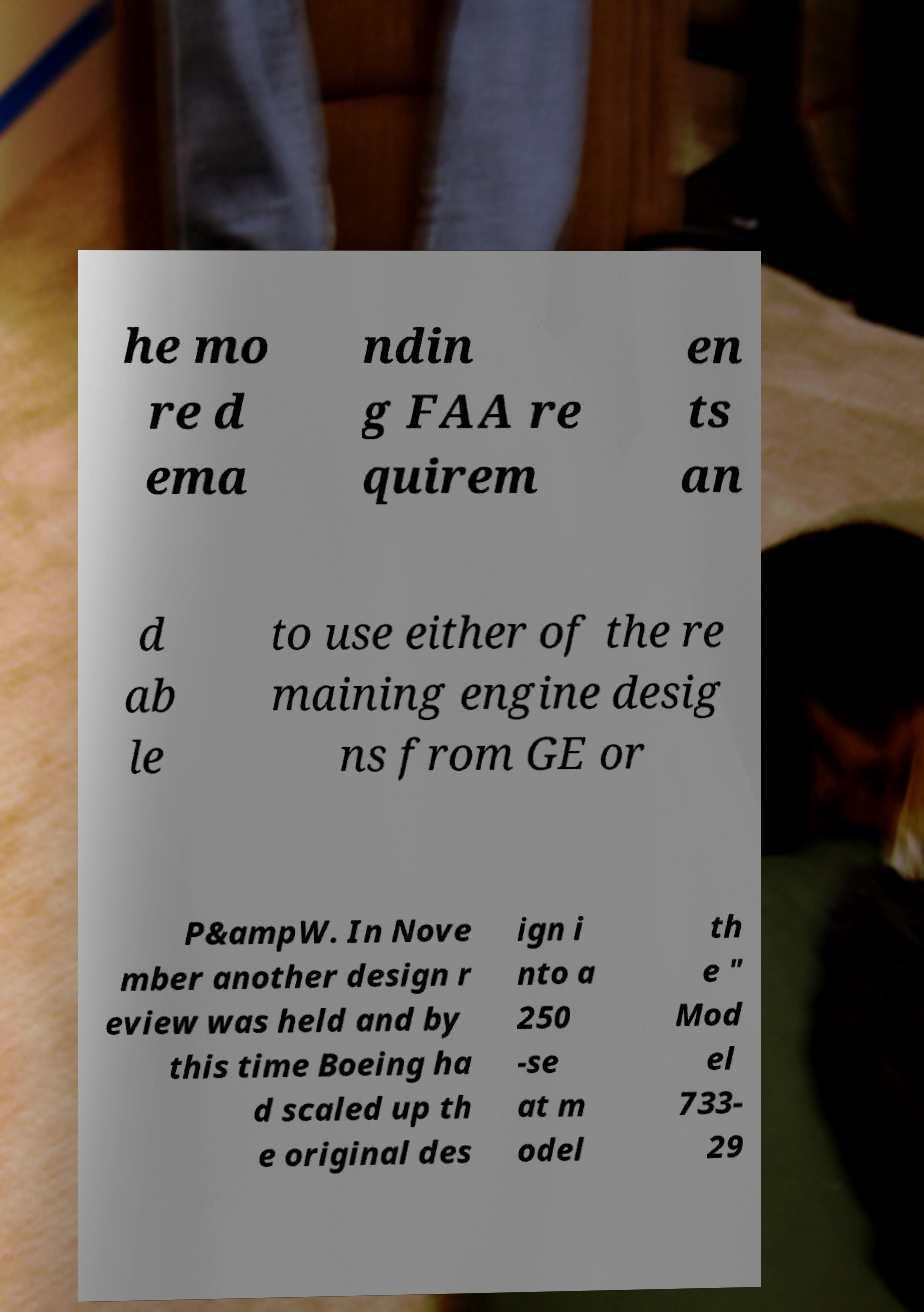Can you read and provide the text displayed in the image?This photo seems to have some interesting text. Can you extract and type it out for me? he mo re d ema ndin g FAA re quirem en ts an d ab le to use either of the re maining engine desig ns from GE or P&ampW. In Nove mber another design r eview was held and by this time Boeing ha d scaled up th e original des ign i nto a 250 -se at m odel th e " Mod el 733- 29 